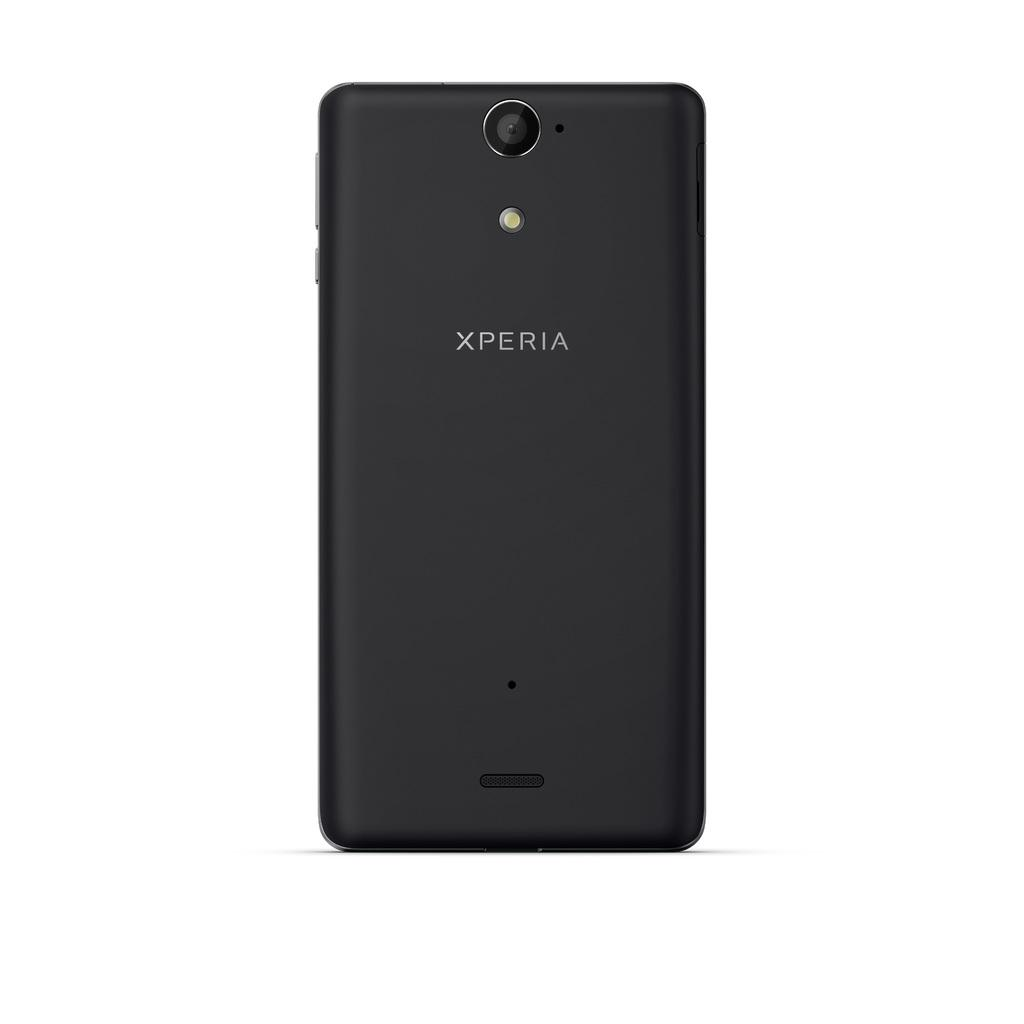<image>
Create a compact narrative representing the image presented. The rear view of an xperia phone by Sony 